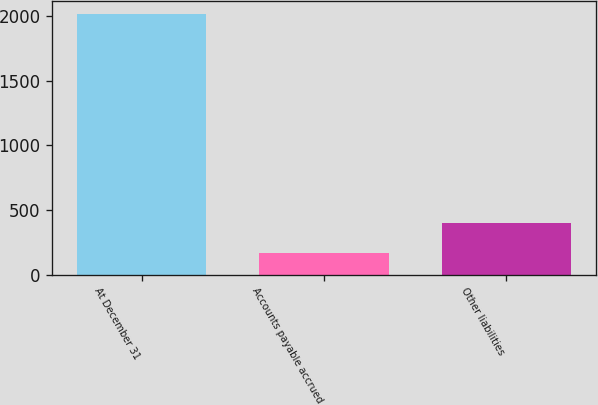Convert chart. <chart><loc_0><loc_0><loc_500><loc_500><bar_chart><fcel>At December 31<fcel>Accounts payable accrued<fcel>Other liabilities<nl><fcel>2016<fcel>162.8<fcel>395.7<nl></chart> 